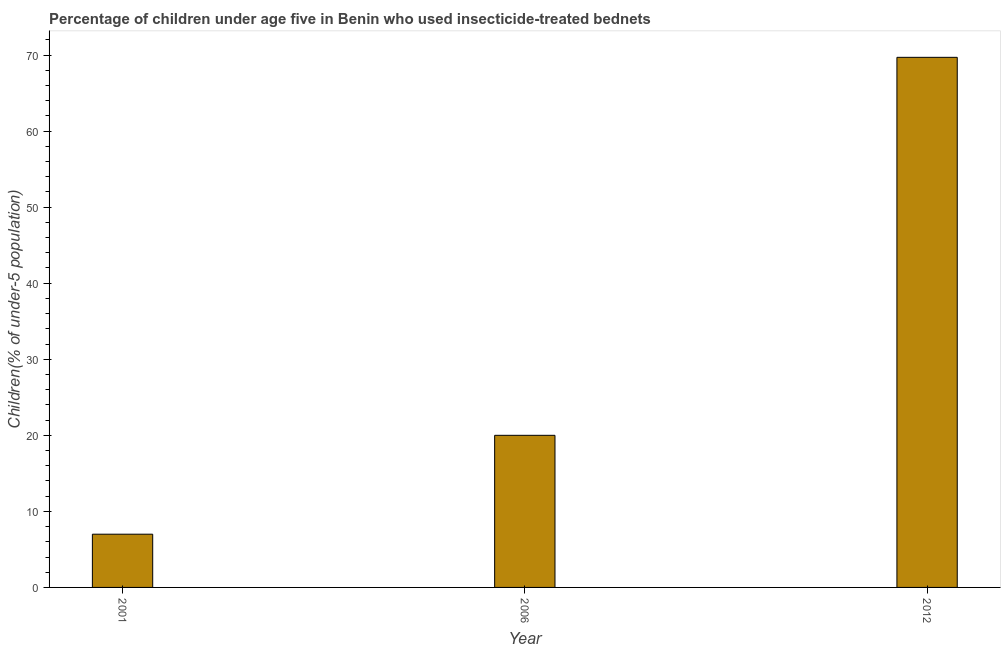Does the graph contain any zero values?
Keep it short and to the point. No. Does the graph contain grids?
Offer a terse response. No. What is the title of the graph?
Provide a short and direct response. Percentage of children under age five in Benin who used insecticide-treated bednets. What is the label or title of the X-axis?
Give a very brief answer. Year. What is the label or title of the Y-axis?
Ensure brevity in your answer.  Children(% of under-5 population). What is the percentage of children who use of insecticide-treated bed nets in 2001?
Provide a short and direct response. 7. Across all years, what is the maximum percentage of children who use of insecticide-treated bed nets?
Ensure brevity in your answer.  69.7. Across all years, what is the minimum percentage of children who use of insecticide-treated bed nets?
Provide a short and direct response. 7. In which year was the percentage of children who use of insecticide-treated bed nets maximum?
Your answer should be very brief. 2012. What is the sum of the percentage of children who use of insecticide-treated bed nets?
Your answer should be very brief. 96.7. What is the difference between the percentage of children who use of insecticide-treated bed nets in 2001 and 2012?
Offer a terse response. -62.7. What is the average percentage of children who use of insecticide-treated bed nets per year?
Your response must be concise. 32.23. In how many years, is the percentage of children who use of insecticide-treated bed nets greater than 56 %?
Give a very brief answer. 1. Do a majority of the years between 2006 and 2012 (inclusive) have percentage of children who use of insecticide-treated bed nets greater than 12 %?
Your response must be concise. Yes. What is the difference between the highest and the second highest percentage of children who use of insecticide-treated bed nets?
Your answer should be very brief. 49.7. Is the sum of the percentage of children who use of insecticide-treated bed nets in 2001 and 2012 greater than the maximum percentage of children who use of insecticide-treated bed nets across all years?
Your response must be concise. Yes. What is the difference between the highest and the lowest percentage of children who use of insecticide-treated bed nets?
Ensure brevity in your answer.  62.7. How many bars are there?
Your answer should be compact. 3. Are all the bars in the graph horizontal?
Make the answer very short. No. How many years are there in the graph?
Offer a very short reply. 3. Are the values on the major ticks of Y-axis written in scientific E-notation?
Ensure brevity in your answer.  No. What is the Children(% of under-5 population) of 2001?
Keep it short and to the point. 7. What is the Children(% of under-5 population) of 2006?
Keep it short and to the point. 20. What is the Children(% of under-5 population) of 2012?
Ensure brevity in your answer.  69.7. What is the difference between the Children(% of under-5 population) in 2001 and 2012?
Ensure brevity in your answer.  -62.7. What is the difference between the Children(% of under-5 population) in 2006 and 2012?
Offer a very short reply. -49.7. What is the ratio of the Children(% of under-5 population) in 2001 to that in 2006?
Provide a short and direct response. 0.35. What is the ratio of the Children(% of under-5 population) in 2001 to that in 2012?
Your answer should be very brief. 0.1. What is the ratio of the Children(% of under-5 population) in 2006 to that in 2012?
Your response must be concise. 0.29. 